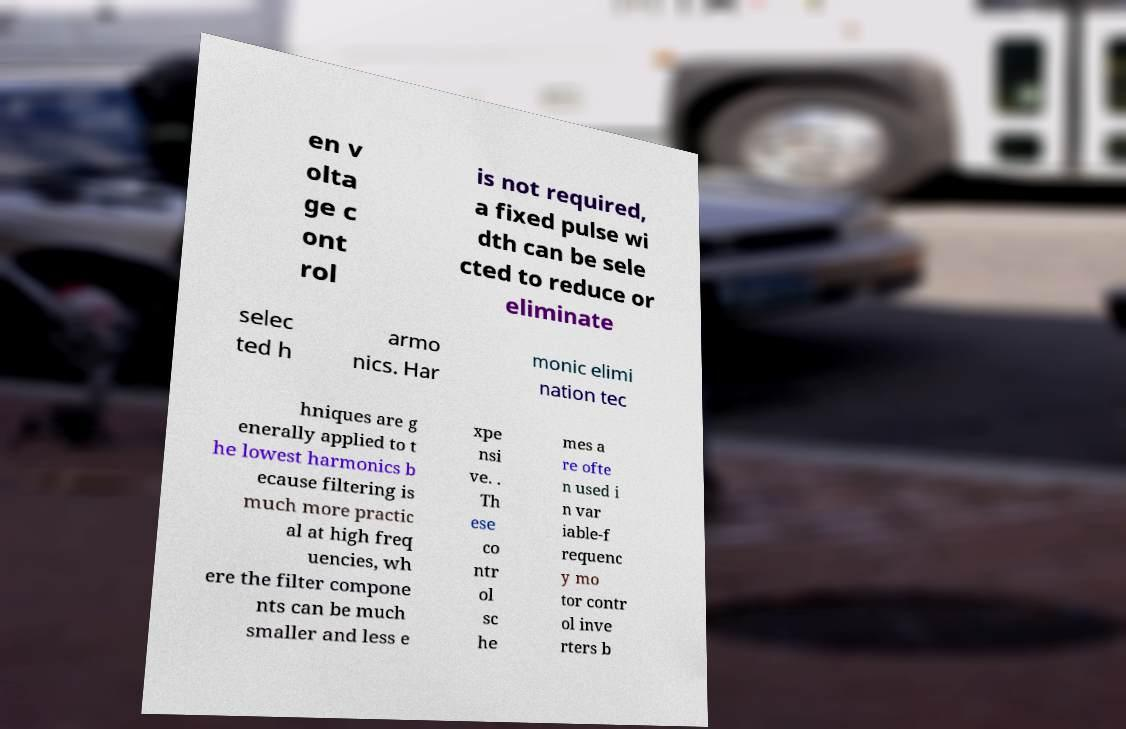Could you extract and type out the text from this image? en v olta ge c ont rol is not required, a fixed pulse wi dth can be sele cted to reduce or eliminate selec ted h armo nics. Har monic elimi nation tec hniques are g enerally applied to t he lowest harmonics b ecause filtering is much more practic al at high freq uencies, wh ere the filter compone nts can be much smaller and less e xpe nsi ve. . Th ese co ntr ol sc he mes a re ofte n used i n var iable-f requenc y mo tor contr ol inve rters b 